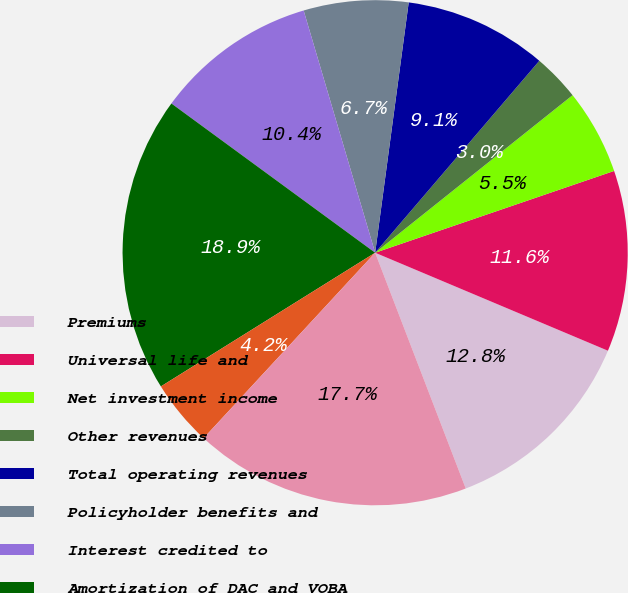Convert chart to OTSL. <chart><loc_0><loc_0><loc_500><loc_500><pie_chart><fcel>Premiums<fcel>Universal life and<fcel>Net investment income<fcel>Other revenues<fcel>Total operating revenues<fcel>Policyholder benefits and<fcel>Interest credited to<fcel>Amortization of DAC and VOBA<fcel>Interest expense on debt<fcel>Other expenses<nl><fcel>12.82%<fcel>11.59%<fcel>5.47%<fcel>3.02%<fcel>9.14%<fcel>6.69%<fcel>10.37%<fcel>18.94%<fcel>4.24%<fcel>17.72%<nl></chart> 